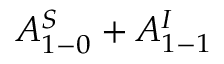<formula> <loc_0><loc_0><loc_500><loc_500>A _ { 1 - 0 } ^ { S } + A _ { 1 - 1 } ^ { I }</formula> 